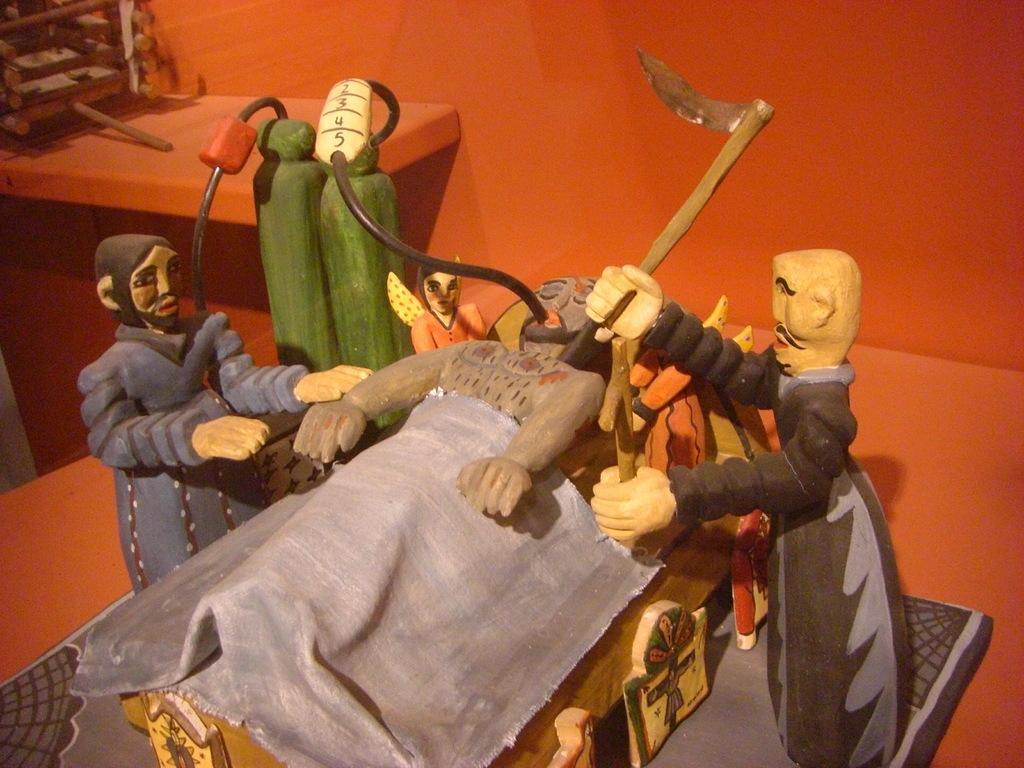Can you describe this image briefly? In this picture there are few toys where there is a person holding an object in his hand in the right corner and there is another person sleeping in front of him and there is a person wearing blue dress is in the left corner and there are green color cylinders beside him and the background is in red and there is an object in the left top corner. 